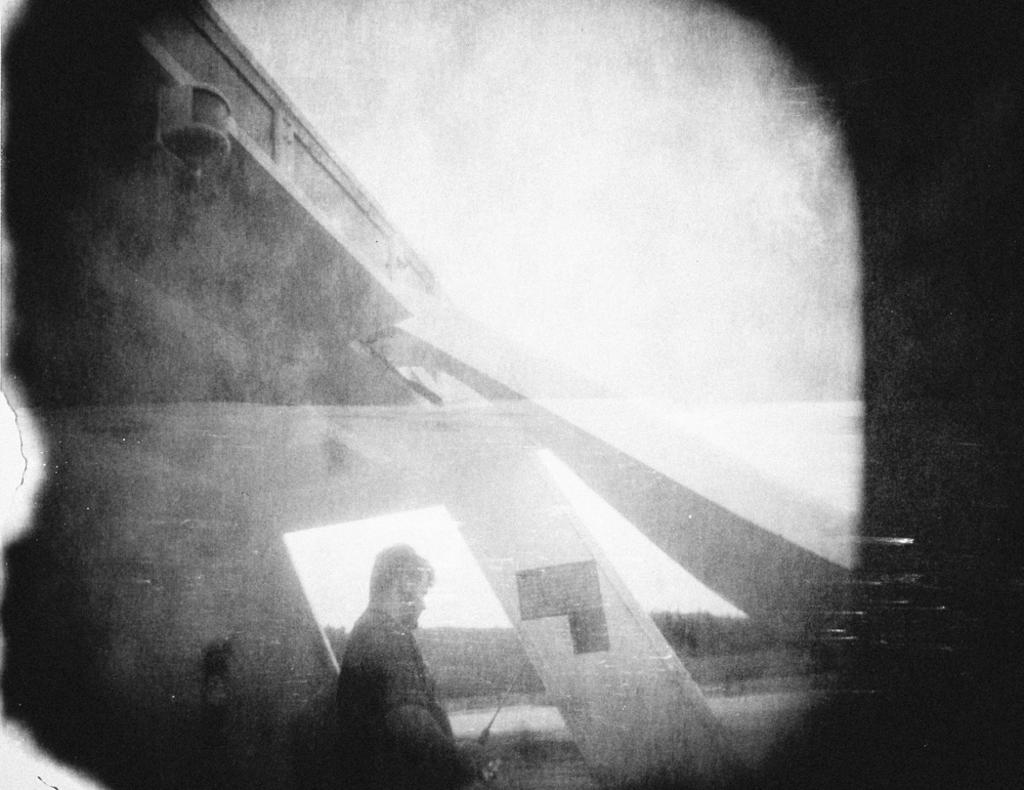What is the main subject of the image? There is a man standing in the image. What can be seen besides the man in the image? There are black objects in the image. What is the color scheme of the image? The image is black and white in color. How many icicles are hanging from the man's hat in the image? There are no icicles present in the image. What effect does the man's presence have on the surrounding environment in the image? The image does not provide information about the man's effect on the environment. 